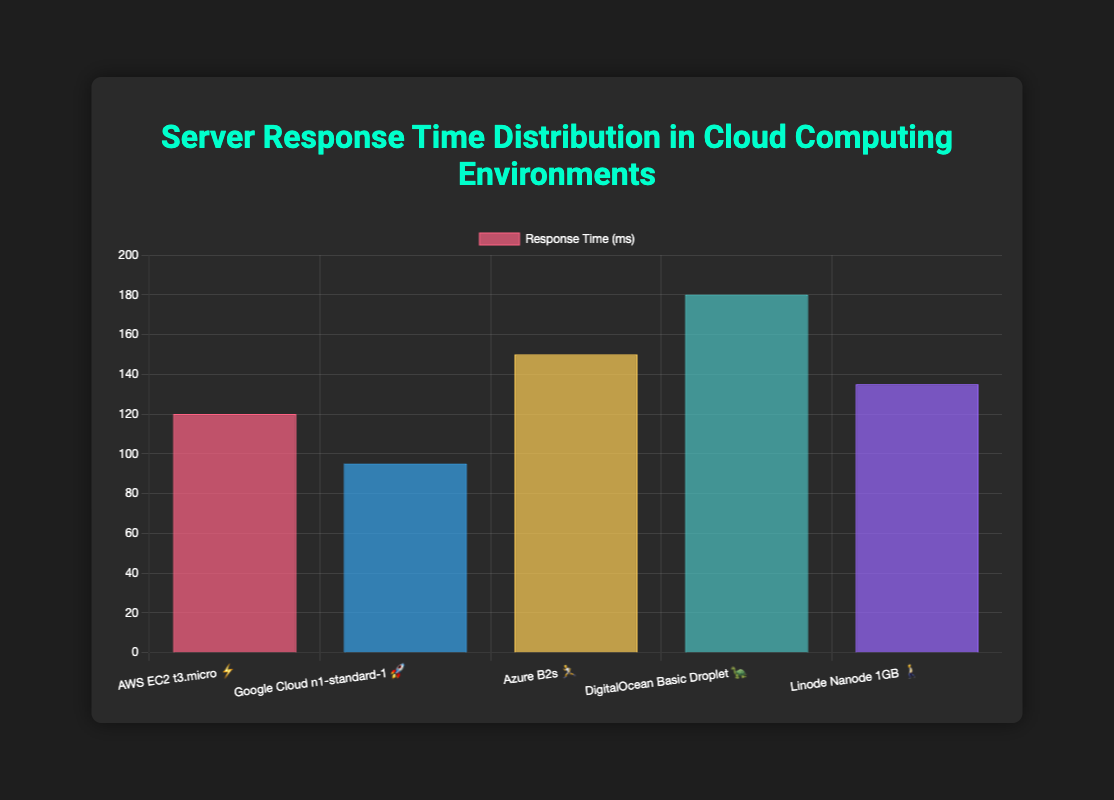What's the title of the chart? The title is usually found at the top of the chart, written in a larger font compared to other text elements. Here, it reads "Server Response Time Distribution in Cloud Computing Environments."
Answer: Server Response Time Distribution in Cloud Computing Environments What is the response time for the Azure B2s server type? Locate the Azure B2s server type on the x-axis along with its corresponding bar and value on the y-axis. It indicates a response time of 150 ms.
Answer: 150 ms Which server type has the fastest response time? The fastest response time is the smallest value on the y-axis. The bar for Google Cloud n1-standard-1 (95 ms) is the shortest.
Answer: Google Cloud n1-standard-1 How many server types are displayed in the chart? Count the number of distinct bars along the x-axis. There are five server types listed on the chart.
Answer: 5 What is the average response time across all server types? Sum each response time (120 + 95 + 150 + 180 + 135) = 680. Divide by the number of server types (5). The average response time is 680/5 = 136 ms.
Answer: 136 ms Which server type has the highest response time? The highest response time is represented by the tallest bar. DigitalOcean Basic Droplet has the highest response time at 180 ms.
Answer: DigitalOcean Basic Droplet How does the response time for Linode Nanode 1GB compare to AWS EC2 t3.micro? Compare the y-axis values: Linode Nanode 1GB (135 ms) and AWS EC2 t3.micro (120 ms). Linode Nanode 1GB has a higher response time by 15 ms.
Answer: Linode Nanode 1GB is 15 ms higher What emojis are associated with the two server types with the fastest response times? Identify the two server types with the smallest bars: Google Cloud n1-standard-1 (95 ms) with 🚀 and AWS EC2 t3.micro (120 ms) with ⚡.
Answer: 🚀 and ⚡ What is the load scenario for the Linode Nanode 1GB server type? Hover or interpret the chart, where the tooltip shows load scenarios as additional information. Linode Nanode 1GB has a "Normal" load scenario.
Answer: Normal 